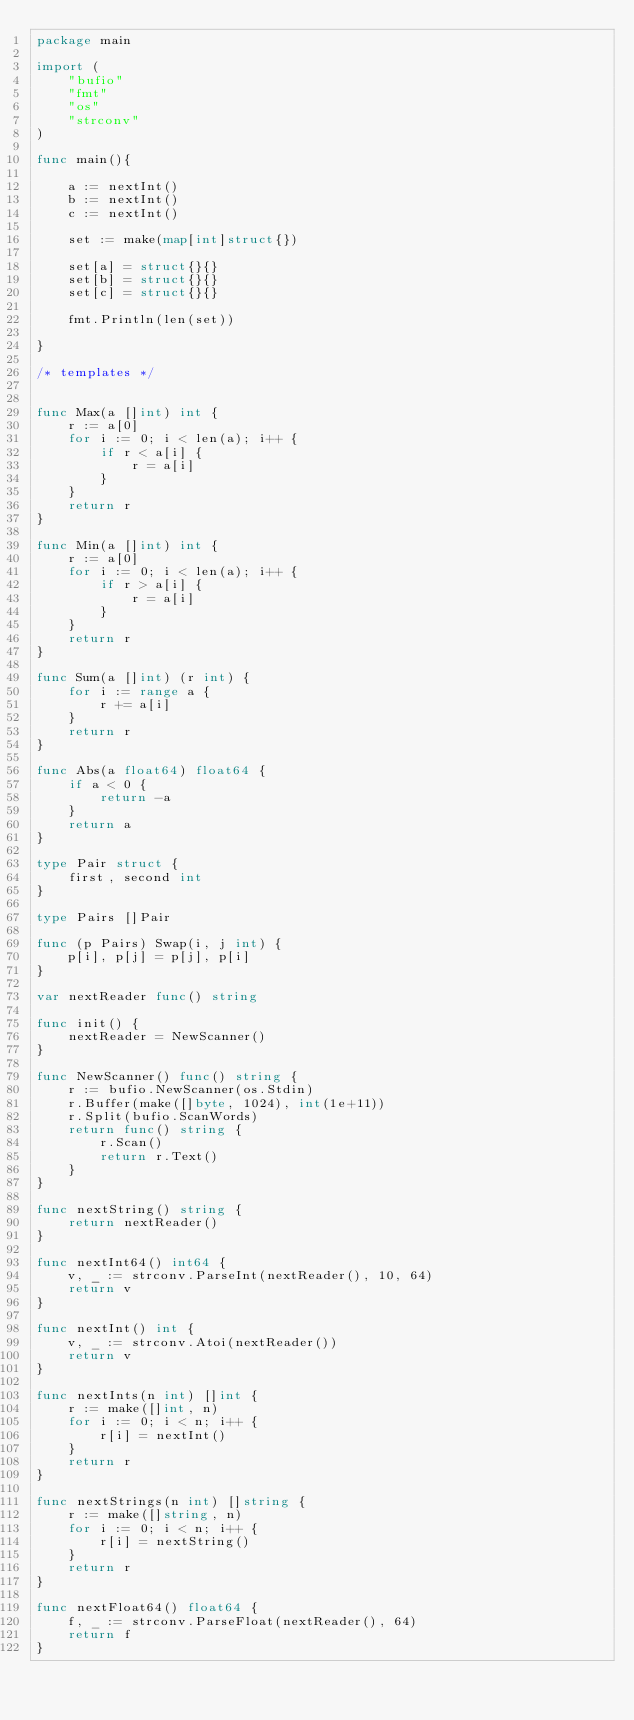Convert code to text. <code><loc_0><loc_0><loc_500><loc_500><_Go_>package main
 
import (
    "bufio"
    "fmt"
    "os"
    "strconv"
)

func main(){
    
    a := nextInt()
    b := nextInt()
    c := nextInt()
    
    set := make(map[int]struct{})
    
    set[a] = struct{}{}
    set[b] = struct{}{}
    set[c] = struct{}{}
    
    fmt.Println(len(set))
    
}

/* templates */


func Max(a []int) int {
    r := a[0]
    for i := 0; i < len(a); i++ {
        if r < a[i] {
            r = a[i]
        }
    }
    return r
}
 
func Min(a []int) int {
    r := a[0]
    for i := 0; i < len(a); i++ {
        if r > a[i] {
            r = a[i]
        }
    }
    return r
}
 
func Sum(a []int) (r int) {
    for i := range a {
        r += a[i]
    }
    return r
}
 
func Abs(a float64) float64 {
    if a < 0 {
        return -a
    }
    return a
}
 
type Pair struct {
    first, second int
}
 
type Pairs []Pair
  
func (p Pairs) Swap(i, j int) {
    p[i], p[j] = p[j], p[i]
}
 
var nextReader func() string
 
func init() {
    nextReader = NewScanner()
}
 
func NewScanner() func() string {
    r := bufio.NewScanner(os.Stdin)
    r.Buffer(make([]byte, 1024), int(1e+11))
    r.Split(bufio.ScanWords)
    return func() string {
        r.Scan()
        return r.Text()
    }
}

func nextString() string {
    return nextReader()
}
 
func nextInt64() int64 {
    v, _ := strconv.ParseInt(nextReader(), 10, 64)
    return v
}
 
func nextInt() int {
    v, _ := strconv.Atoi(nextReader())
    return v
}
 
func nextInts(n int) []int {
    r := make([]int, n)
    for i := 0; i < n; i++ {
        r[i] = nextInt()
    }
    return r
}

func nextStrings(n int) []string {
    r := make([]string, n)
    for i := 0; i < n; i++ {
        r[i] = nextString()
    }
    return r
}

func nextFloat64() float64 {
    f, _ := strconv.ParseFloat(nextReader(), 64)
    return f
}
</code> 